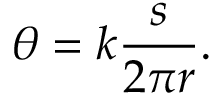Convert formula to latex. <formula><loc_0><loc_0><loc_500><loc_500>\theta = k { \frac { s } { 2 \pi r } } .</formula> 